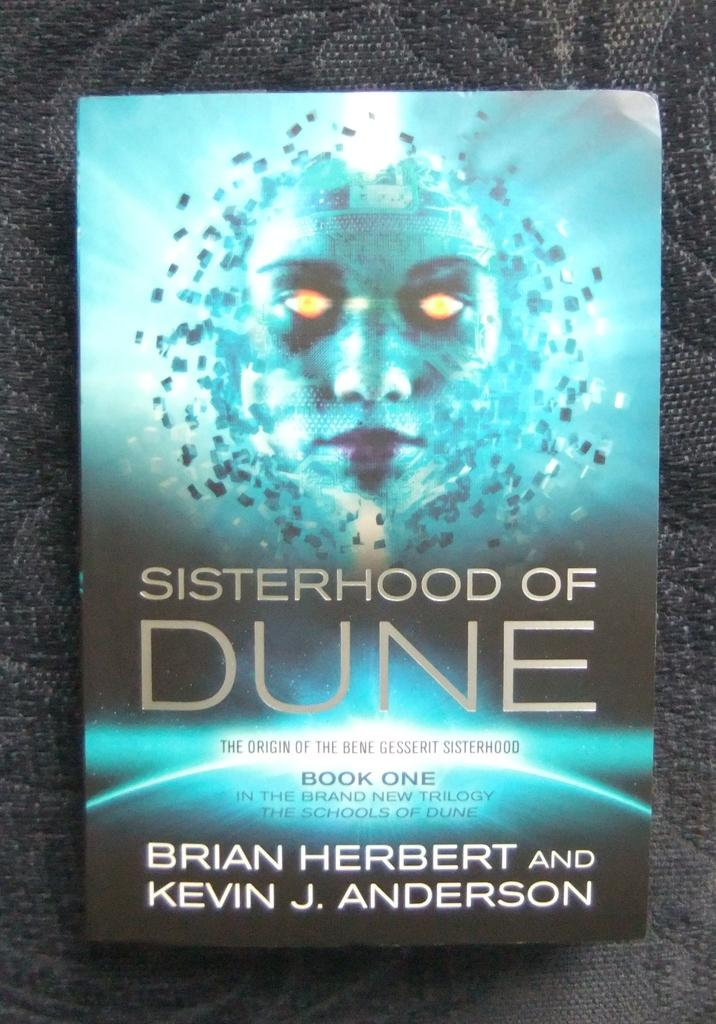<image>
Relay a brief, clear account of the picture shown. The book shown is only book one in a trilogy of books about the same topic. 